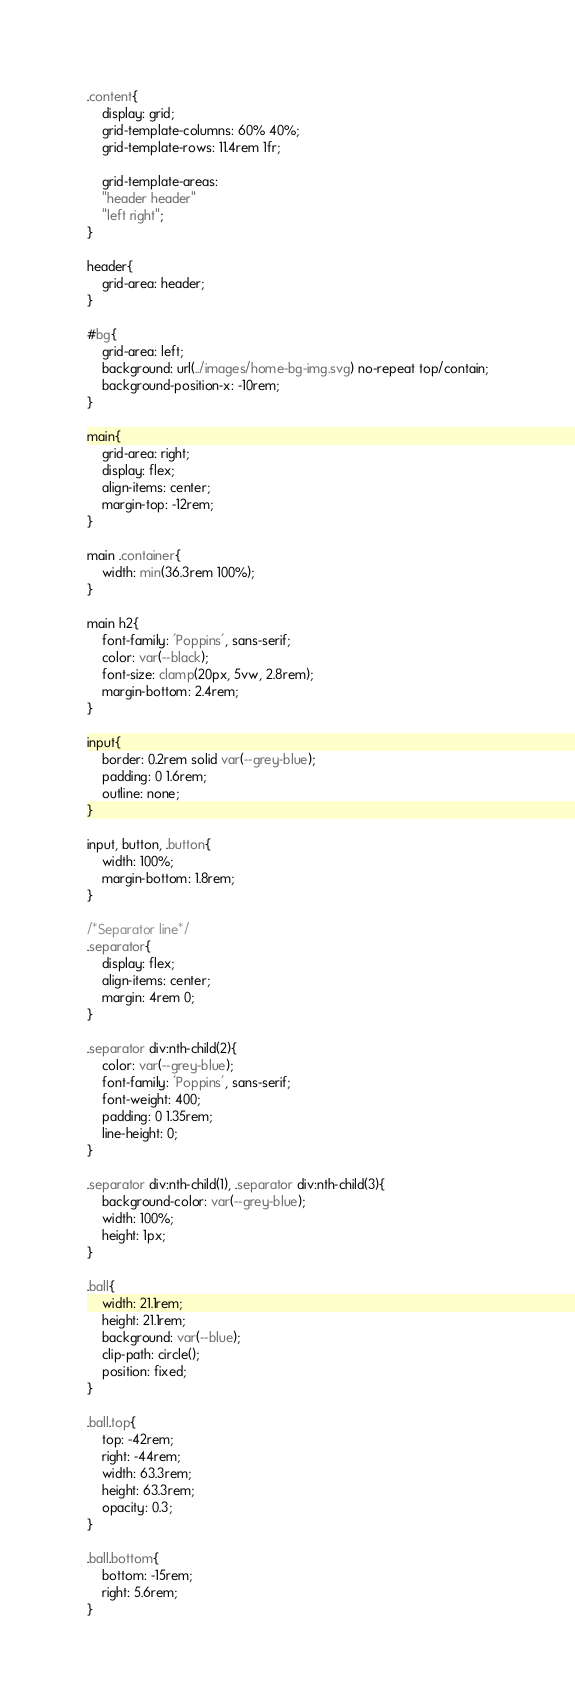Convert code to text. <code><loc_0><loc_0><loc_500><loc_500><_CSS_>.content{
    display: grid;
    grid-template-columns: 60% 40%;
    grid-template-rows: 11.4rem 1fr;

    grid-template-areas: 
    "header header"
    "left right";
}

header{
    grid-area: header;
}

#bg{
    grid-area: left;
    background: url(../images/home-bg-img.svg) no-repeat top/contain;
    background-position-x: -10rem;
}

main{
    grid-area: right;
    display: flex;
    align-items: center;
    margin-top: -12rem;
}

main .container{
    width: min(36.3rem 100%);
}

main h2{
    font-family: 'Poppins', sans-serif;
    color: var(--black);
    font-size: clamp(20px, 5vw, 2.8rem);
    margin-bottom: 2.4rem;
}

input{
    border: 0.2rem solid var(--grey-blue);
    padding: 0 1.6rem;
    outline: none;
}

input, button, .button{
    width: 100%;
    margin-bottom: 1.8rem;
}

/*Separator line*/
.separator{
    display: flex;
    align-items: center;
    margin: 4rem 0;
}

.separator div:nth-child(2){
    color: var(--grey-blue);
    font-family: 'Poppins', sans-serif;
    font-weight: 400;
    padding: 0 1.35rem;
    line-height: 0;
}

.separator div:nth-child(1), .separator div:nth-child(3){
    background-color: var(--grey-blue);
    width: 100%;
    height: 1px;
}

.ball{
    width: 21.1rem;
    height: 21.1rem;
    background: var(--blue);
    clip-path: circle();
    position: fixed;
}

.ball.top{
    top: -42rem;
    right: -44rem;
    width: 63.3rem;
    height: 63.3rem;
    opacity: 0.3;
}

.ball.bottom{
    bottom: -15rem;
    right: 5.6rem;
}
</code> 